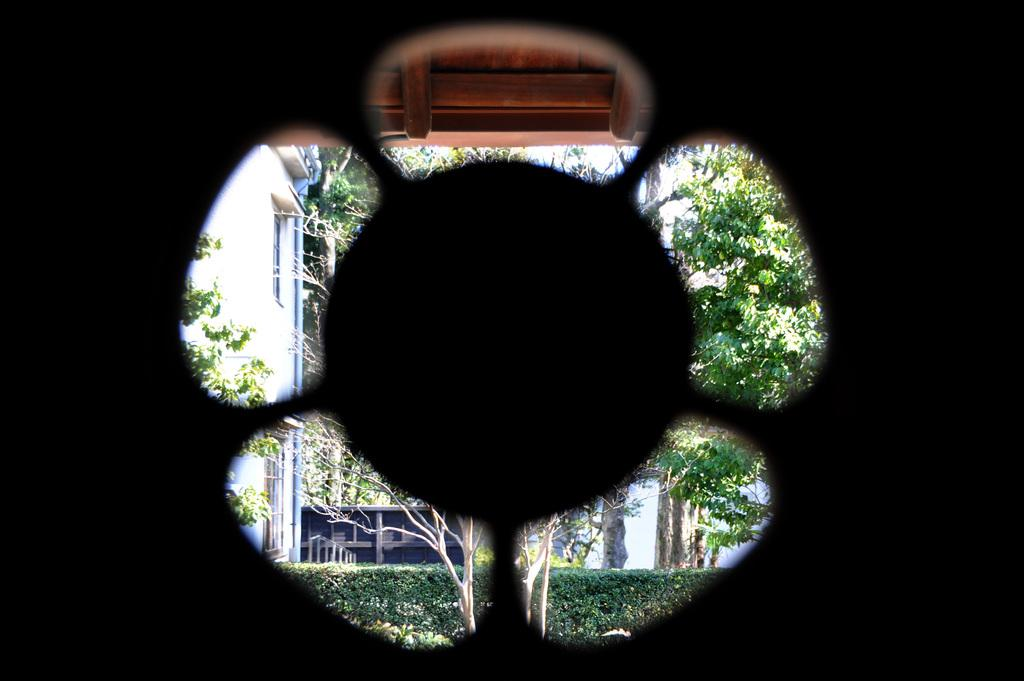What can be seen through the window in the image? Buildings and trees are visible through the window in the image. Can you describe the view from the window? The view from the window includes buildings and trees. What is the name of the person standing next to the window in the image? There is no person standing next to the window in the image. What type of sweater is the person wearing in the image? There is no person present in the image, so there is no sweater to describe. 